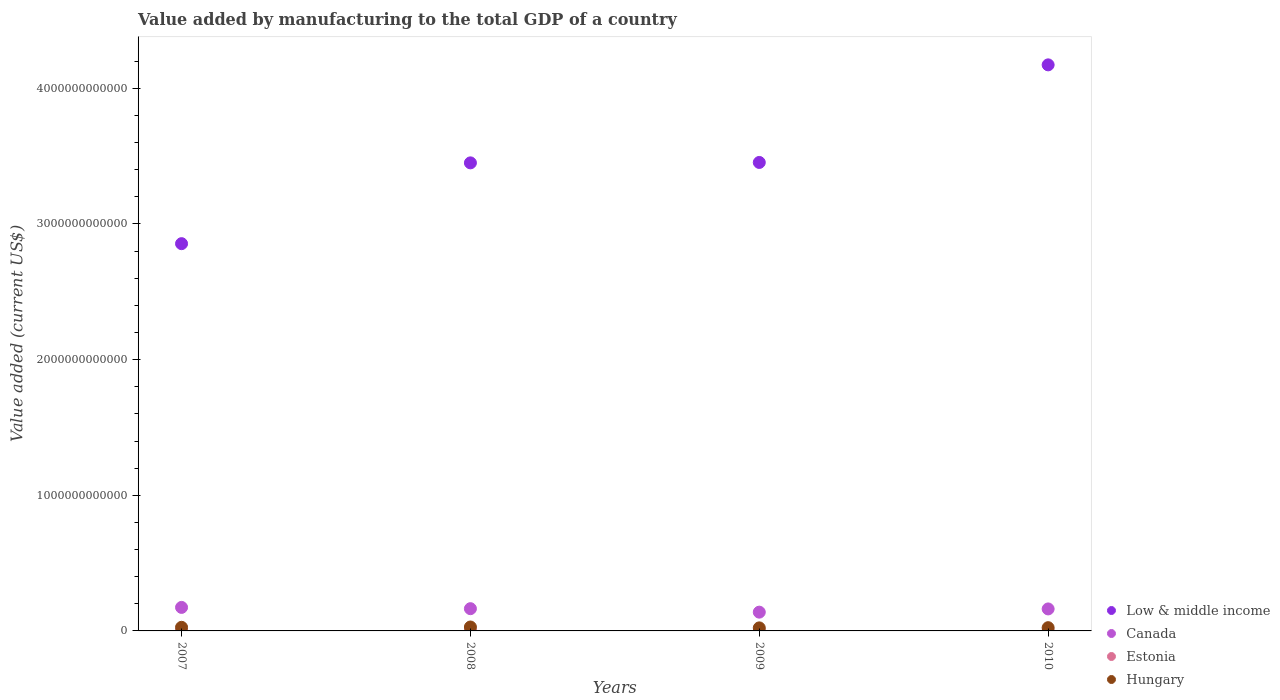How many different coloured dotlines are there?
Provide a short and direct response. 4. What is the value added by manufacturing to the total GDP in Canada in 2010?
Offer a terse response. 1.62e+11. Across all years, what is the maximum value added by manufacturing to the total GDP in Hungary?
Your answer should be very brief. 2.88e+1. Across all years, what is the minimum value added by manufacturing to the total GDP in Canada?
Offer a terse response. 1.38e+11. In which year was the value added by manufacturing to the total GDP in Estonia maximum?
Keep it short and to the point. 2008. What is the total value added by manufacturing to the total GDP in Estonia in the graph?
Your answer should be compact. 1.15e+1. What is the difference between the value added by manufacturing to the total GDP in Hungary in 2007 and that in 2010?
Offer a very short reply. 2.71e+09. What is the difference between the value added by manufacturing to the total GDP in Low & middle income in 2007 and the value added by manufacturing to the total GDP in Canada in 2009?
Provide a succinct answer. 2.72e+12. What is the average value added by manufacturing to the total GDP in Hungary per year?
Make the answer very short. 2.54e+1. In the year 2009, what is the difference between the value added by manufacturing to the total GDP in Low & middle income and value added by manufacturing to the total GDP in Canada?
Provide a short and direct response. 3.32e+12. In how many years, is the value added by manufacturing to the total GDP in Estonia greater than 1400000000000 US$?
Make the answer very short. 0. What is the ratio of the value added by manufacturing to the total GDP in Low & middle income in 2007 to that in 2009?
Give a very brief answer. 0.83. Is the value added by manufacturing to the total GDP in Estonia in 2007 less than that in 2009?
Provide a short and direct response. No. Is the difference between the value added by manufacturing to the total GDP in Low & middle income in 2009 and 2010 greater than the difference between the value added by manufacturing to the total GDP in Canada in 2009 and 2010?
Keep it short and to the point. No. What is the difference between the highest and the second highest value added by manufacturing to the total GDP in Hungary?
Your answer should be compact. 2.23e+09. What is the difference between the highest and the lowest value added by manufacturing to the total GDP in Hungary?
Make the answer very short. 6.42e+09. Is the sum of the value added by manufacturing to the total GDP in Hungary in 2007 and 2008 greater than the maximum value added by manufacturing to the total GDP in Canada across all years?
Your answer should be compact. No. Does the value added by manufacturing to the total GDP in Estonia monotonically increase over the years?
Your answer should be very brief. No. What is the difference between two consecutive major ticks on the Y-axis?
Your response must be concise. 1.00e+12. Are the values on the major ticks of Y-axis written in scientific E-notation?
Offer a terse response. No. Does the graph contain grids?
Make the answer very short. No. Where does the legend appear in the graph?
Give a very brief answer. Bottom right. How many legend labels are there?
Provide a short and direct response. 4. What is the title of the graph?
Provide a succinct answer. Value added by manufacturing to the total GDP of a country. Does "Vietnam" appear as one of the legend labels in the graph?
Offer a terse response. No. What is the label or title of the X-axis?
Your response must be concise. Years. What is the label or title of the Y-axis?
Your answer should be compact. Value added (current US$). What is the Value added (current US$) in Low & middle income in 2007?
Your answer should be very brief. 2.85e+12. What is the Value added (current US$) in Canada in 2007?
Offer a very short reply. 1.73e+11. What is the Value added (current US$) in Estonia in 2007?
Ensure brevity in your answer.  3.11e+09. What is the Value added (current US$) in Hungary in 2007?
Your answer should be very brief. 2.66e+1. What is the Value added (current US$) of Low & middle income in 2008?
Make the answer very short. 3.45e+12. What is the Value added (current US$) of Canada in 2008?
Your response must be concise. 1.64e+11. What is the Value added (current US$) of Estonia in 2008?
Offer a terse response. 3.34e+09. What is the Value added (current US$) in Hungary in 2008?
Provide a short and direct response. 2.88e+1. What is the Value added (current US$) in Low & middle income in 2009?
Give a very brief answer. 3.45e+12. What is the Value added (current US$) of Canada in 2009?
Your response must be concise. 1.38e+11. What is the Value added (current US$) of Estonia in 2009?
Keep it short and to the point. 2.41e+09. What is the Value added (current US$) in Hungary in 2009?
Offer a terse response. 2.24e+1. What is the Value added (current US$) of Low & middle income in 2010?
Make the answer very short. 4.17e+12. What is the Value added (current US$) of Canada in 2010?
Your answer should be very brief. 1.62e+11. What is the Value added (current US$) in Estonia in 2010?
Offer a terse response. 2.68e+09. What is the Value added (current US$) of Hungary in 2010?
Your answer should be very brief. 2.39e+1. Across all years, what is the maximum Value added (current US$) of Low & middle income?
Ensure brevity in your answer.  4.17e+12. Across all years, what is the maximum Value added (current US$) of Canada?
Your answer should be compact. 1.73e+11. Across all years, what is the maximum Value added (current US$) of Estonia?
Offer a very short reply. 3.34e+09. Across all years, what is the maximum Value added (current US$) of Hungary?
Make the answer very short. 2.88e+1. Across all years, what is the minimum Value added (current US$) of Low & middle income?
Provide a succinct answer. 2.85e+12. Across all years, what is the minimum Value added (current US$) in Canada?
Provide a succinct answer. 1.38e+11. Across all years, what is the minimum Value added (current US$) of Estonia?
Offer a very short reply. 2.41e+09. Across all years, what is the minimum Value added (current US$) in Hungary?
Your answer should be very brief. 2.24e+1. What is the total Value added (current US$) in Low & middle income in the graph?
Offer a very short reply. 1.39e+13. What is the total Value added (current US$) of Canada in the graph?
Your response must be concise. 6.38e+11. What is the total Value added (current US$) in Estonia in the graph?
Keep it short and to the point. 1.15e+1. What is the total Value added (current US$) of Hungary in the graph?
Ensure brevity in your answer.  1.02e+11. What is the difference between the Value added (current US$) in Low & middle income in 2007 and that in 2008?
Give a very brief answer. -5.96e+11. What is the difference between the Value added (current US$) in Canada in 2007 and that in 2008?
Your response must be concise. 9.42e+09. What is the difference between the Value added (current US$) of Estonia in 2007 and that in 2008?
Keep it short and to the point. -2.29e+08. What is the difference between the Value added (current US$) in Hungary in 2007 and that in 2008?
Your answer should be compact. -2.23e+09. What is the difference between the Value added (current US$) of Low & middle income in 2007 and that in 2009?
Ensure brevity in your answer.  -5.99e+11. What is the difference between the Value added (current US$) of Canada in 2007 and that in 2009?
Provide a short and direct response. 3.50e+1. What is the difference between the Value added (current US$) of Estonia in 2007 and that in 2009?
Offer a terse response. 6.98e+08. What is the difference between the Value added (current US$) of Hungary in 2007 and that in 2009?
Ensure brevity in your answer.  4.19e+09. What is the difference between the Value added (current US$) of Low & middle income in 2007 and that in 2010?
Provide a short and direct response. -1.32e+12. What is the difference between the Value added (current US$) in Canada in 2007 and that in 2010?
Make the answer very short. 1.13e+1. What is the difference between the Value added (current US$) in Estonia in 2007 and that in 2010?
Keep it short and to the point. 4.33e+08. What is the difference between the Value added (current US$) in Hungary in 2007 and that in 2010?
Offer a very short reply. 2.71e+09. What is the difference between the Value added (current US$) in Low & middle income in 2008 and that in 2009?
Offer a terse response. -3.05e+09. What is the difference between the Value added (current US$) in Canada in 2008 and that in 2009?
Ensure brevity in your answer.  2.56e+1. What is the difference between the Value added (current US$) in Estonia in 2008 and that in 2009?
Provide a succinct answer. 9.27e+08. What is the difference between the Value added (current US$) of Hungary in 2008 and that in 2009?
Your answer should be compact. 6.42e+09. What is the difference between the Value added (current US$) of Low & middle income in 2008 and that in 2010?
Your answer should be compact. -7.22e+11. What is the difference between the Value added (current US$) in Canada in 2008 and that in 2010?
Ensure brevity in your answer.  1.87e+09. What is the difference between the Value added (current US$) in Estonia in 2008 and that in 2010?
Your response must be concise. 6.62e+08. What is the difference between the Value added (current US$) of Hungary in 2008 and that in 2010?
Make the answer very short. 4.94e+09. What is the difference between the Value added (current US$) in Low & middle income in 2009 and that in 2010?
Ensure brevity in your answer.  -7.19e+11. What is the difference between the Value added (current US$) of Canada in 2009 and that in 2010?
Your answer should be compact. -2.37e+1. What is the difference between the Value added (current US$) in Estonia in 2009 and that in 2010?
Provide a succinct answer. -2.65e+08. What is the difference between the Value added (current US$) in Hungary in 2009 and that in 2010?
Keep it short and to the point. -1.48e+09. What is the difference between the Value added (current US$) in Low & middle income in 2007 and the Value added (current US$) in Canada in 2008?
Your answer should be compact. 2.69e+12. What is the difference between the Value added (current US$) of Low & middle income in 2007 and the Value added (current US$) of Estonia in 2008?
Your answer should be compact. 2.85e+12. What is the difference between the Value added (current US$) in Low & middle income in 2007 and the Value added (current US$) in Hungary in 2008?
Make the answer very short. 2.83e+12. What is the difference between the Value added (current US$) of Canada in 2007 and the Value added (current US$) of Estonia in 2008?
Provide a succinct answer. 1.70e+11. What is the difference between the Value added (current US$) in Canada in 2007 and the Value added (current US$) in Hungary in 2008?
Your answer should be compact. 1.45e+11. What is the difference between the Value added (current US$) of Estonia in 2007 and the Value added (current US$) of Hungary in 2008?
Offer a very short reply. -2.57e+1. What is the difference between the Value added (current US$) in Low & middle income in 2007 and the Value added (current US$) in Canada in 2009?
Give a very brief answer. 2.72e+12. What is the difference between the Value added (current US$) of Low & middle income in 2007 and the Value added (current US$) of Estonia in 2009?
Provide a short and direct response. 2.85e+12. What is the difference between the Value added (current US$) in Low & middle income in 2007 and the Value added (current US$) in Hungary in 2009?
Your response must be concise. 2.83e+12. What is the difference between the Value added (current US$) in Canada in 2007 and the Value added (current US$) in Estonia in 2009?
Provide a succinct answer. 1.71e+11. What is the difference between the Value added (current US$) in Canada in 2007 and the Value added (current US$) in Hungary in 2009?
Give a very brief answer. 1.51e+11. What is the difference between the Value added (current US$) in Estonia in 2007 and the Value added (current US$) in Hungary in 2009?
Offer a terse response. -1.93e+1. What is the difference between the Value added (current US$) of Low & middle income in 2007 and the Value added (current US$) of Canada in 2010?
Your answer should be very brief. 2.69e+12. What is the difference between the Value added (current US$) in Low & middle income in 2007 and the Value added (current US$) in Estonia in 2010?
Provide a succinct answer. 2.85e+12. What is the difference between the Value added (current US$) of Low & middle income in 2007 and the Value added (current US$) of Hungary in 2010?
Make the answer very short. 2.83e+12. What is the difference between the Value added (current US$) of Canada in 2007 and the Value added (current US$) of Estonia in 2010?
Provide a succinct answer. 1.71e+11. What is the difference between the Value added (current US$) in Canada in 2007 and the Value added (current US$) in Hungary in 2010?
Provide a short and direct response. 1.49e+11. What is the difference between the Value added (current US$) in Estonia in 2007 and the Value added (current US$) in Hungary in 2010?
Make the answer very short. -2.08e+1. What is the difference between the Value added (current US$) of Low & middle income in 2008 and the Value added (current US$) of Canada in 2009?
Provide a short and direct response. 3.31e+12. What is the difference between the Value added (current US$) in Low & middle income in 2008 and the Value added (current US$) in Estonia in 2009?
Make the answer very short. 3.45e+12. What is the difference between the Value added (current US$) in Low & middle income in 2008 and the Value added (current US$) in Hungary in 2009?
Your response must be concise. 3.43e+12. What is the difference between the Value added (current US$) in Canada in 2008 and the Value added (current US$) in Estonia in 2009?
Your answer should be compact. 1.62e+11. What is the difference between the Value added (current US$) in Canada in 2008 and the Value added (current US$) in Hungary in 2009?
Provide a succinct answer. 1.42e+11. What is the difference between the Value added (current US$) of Estonia in 2008 and the Value added (current US$) of Hungary in 2009?
Offer a very short reply. -1.91e+1. What is the difference between the Value added (current US$) of Low & middle income in 2008 and the Value added (current US$) of Canada in 2010?
Ensure brevity in your answer.  3.29e+12. What is the difference between the Value added (current US$) of Low & middle income in 2008 and the Value added (current US$) of Estonia in 2010?
Provide a short and direct response. 3.45e+12. What is the difference between the Value added (current US$) in Low & middle income in 2008 and the Value added (current US$) in Hungary in 2010?
Your answer should be compact. 3.43e+12. What is the difference between the Value added (current US$) in Canada in 2008 and the Value added (current US$) in Estonia in 2010?
Keep it short and to the point. 1.61e+11. What is the difference between the Value added (current US$) of Canada in 2008 and the Value added (current US$) of Hungary in 2010?
Offer a terse response. 1.40e+11. What is the difference between the Value added (current US$) in Estonia in 2008 and the Value added (current US$) in Hungary in 2010?
Keep it short and to the point. -2.05e+1. What is the difference between the Value added (current US$) in Low & middle income in 2009 and the Value added (current US$) in Canada in 2010?
Provide a succinct answer. 3.29e+12. What is the difference between the Value added (current US$) of Low & middle income in 2009 and the Value added (current US$) of Estonia in 2010?
Your answer should be compact. 3.45e+12. What is the difference between the Value added (current US$) in Low & middle income in 2009 and the Value added (current US$) in Hungary in 2010?
Offer a very short reply. 3.43e+12. What is the difference between the Value added (current US$) in Canada in 2009 and the Value added (current US$) in Estonia in 2010?
Ensure brevity in your answer.  1.36e+11. What is the difference between the Value added (current US$) of Canada in 2009 and the Value added (current US$) of Hungary in 2010?
Give a very brief answer. 1.14e+11. What is the difference between the Value added (current US$) in Estonia in 2009 and the Value added (current US$) in Hungary in 2010?
Provide a succinct answer. -2.15e+1. What is the average Value added (current US$) in Low & middle income per year?
Provide a succinct answer. 3.48e+12. What is the average Value added (current US$) of Canada per year?
Your response must be concise. 1.59e+11. What is the average Value added (current US$) of Estonia per year?
Offer a terse response. 2.88e+09. What is the average Value added (current US$) in Hungary per year?
Offer a very short reply. 2.54e+1. In the year 2007, what is the difference between the Value added (current US$) in Low & middle income and Value added (current US$) in Canada?
Offer a very short reply. 2.68e+12. In the year 2007, what is the difference between the Value added (current US$) in Low & middle income and Value added (current US$) in Estonia?
Give a very brief answer. 2.85e+12. In the year 2007, what is the difference between the Value added (current US$) of Low & middle income and Value added (current US$) of Hungary?
Offer a very short reply. 2.83e+12. In the year 2007, what is the difference between the Value added (current US$) in Canada and Value added (current US$) in Estonia?
Keep it short and to the point. 1.70e+11. In the year 2007, what is the difference between the Value added (current US$) in Canada and Value added (current US$) in Hungary?
Your answer should be compact. 1.47e+11. In the year 2007, what is the difference between the Value added (current US$) of Estonia and Value added (current US$) of Hungary?
Offer a terse response. -2.35e+1. In the year 2008, what is the difference between the Value added (current US$) of Low & middle income and Value added (current US$) of Canada?
Make the answer very short. 3.29e+12. In the year 2008, what is the difference between the Value added (current US$) of Low & middle income and Value added (current US$) of Estonia?
Your response must be concise. 3.45e+12. In the year 2008, what is the difference between the Value added (current US$) of Low & middle income and Value added (current US$) of Hungary?
Your answer should be compact. 3.42e+12. In the year 2008, what is the difference between the Value added (current US$) of Canada and Value added (current US$) of Estonia?
Offer a very short reply. 1.61e+11. In the year 2008, what is the difference between the Value added (current US$) of Canada and Value added (current US$) of Hungary?
Your response must be concise. 1.35e+11. In the year 2008, what is the difference between the Value added (current US$) in Estonia and Value added (current US$) in Hungary?
Offer a terse response. -2.55e+1. In the year 2009, what is the difference between the Value added (current US$) in Low & middle income and Value added (current US$) in Canada?
Your response must be concise. 3.32e+12. In the year 2009, what is the difference between the Value added (current US$) in Low & middle income and Value added (current US$) in Estonia?
Offer a very short reply. 3.45e+12. In the year 2009, what is the difference between the Value added (current US$) of Low & middle income and Value added (current US$) of Hungary?
Offer a very short reply. 3.43e+12. In the year 2009, what is the difference between the Value added (current US$) in Canada and Value added (current US$) in Estonia?
Provide a succinct answer. 1.36e+11. In the year 2009, what is the difference between the Value added (current US$) of Canada and Value added (current US$) of Hungary?
Give a very brief answer. 1.16e+11. In the year 2009, what is the difference between the Value added (current US$) in Estonia and Value added (current US$) in Hungary?
Your answer should be compact. -2.00e+1. In the year 2010, what is the difference between the Value added (current US$) in Low & middle income and Value added (current US$) in Canada?
Your answer should be compact. 4.01e+12. In the year 2010, what is the difference between the Value added (current US$) of Low & middle income and Value added (current US$) of Estonia?
Offer a very short reply. 4.17e+12. In the year 2010, what is the difference between the Value added (current US$) of Low & middle income and Value added (current US$) of Hungary?
Offer a very short reply. 4.15e+12. In the year 2010, what is the difference between the Value added (current US$) in Canada and Value added (current US$) in Estonia?
Give a very brief answer. 1.59e+11. In the year 2010, what is the difference between the Value added (current US$) of Canada and Value added (current US$) of Hungary?
Your response must be concise. 1.38e+11. In the year 2010, what is the difference between the Value added (current US$) of Estonia and Value added (current US$) of Hungary?
Give a very brief answer. -2.12e+1. What is the ratio of the Value added (current US$) of Low & middle income in 2007 to that in 2008?
Your answer should be compact. 0.83. What is the ratio of the Value added (current US$) of Canada in 2007 to that in 2008?
Offer a very short reply. 1.06. What is the ratio of the Value added (current US$) of Estonia in 2007 to that in 2008?
Ensure brevity in your answer.  0.93. What is the ratio of the Value added (current US$) of Hungary in 2007 to that in 2008?
Offer a very short reply. 0.92. What is the ratio of the Value added (current US$) of Low & middle income in 2007 to that in 2009?
Offer a very short reply. 0.83. What is the ratio of the Value added (current US$) in Canada in 2007 to that in 2009?
Ensure brevity in your answer.  1.25. What is the ratio of the Value added (current US$) of Estonia in 2007 to that in 2009?
Keep it short and to the point. 1.29. What is the ratio of the Value added (current US$) of Hungary in 2007 to that in 2009?
Provide a succinct answer. 1.19. What is the ratio of the Value added (current US$) in Low & middle income in 2007 to that in 2010?
Your answer should be compact. 0.68. What is the ratio of the Value added (current US$) of Canada in 2007 to that in 2010?
Your answer should be very brief. 1.07. What is the ratio of the Value added (current US$) in Estonia in 2007 to that in 2010?
Your answer should be compact. 1.16. What is the ratio of the Value added (current US$) of Hungary in 2007 to that in 2010?
Give a very brief answer. 1.11. What is the ratio of the Value added (current US$) of Canada in 2008 to that in 2009?
Ensure brevity in your answer.  1.19. What is the ratio of the Value added (current US$) in Estonia in 2008 to that in 2009?
Offer a terse response. 1.38. What is the ratio of the Value added (current US$) of Hungary in 2008 to that in 2009?
Offer a very short reply. 1.29. What is the ratio of the Value added (current US$) in Low & middle income in 2008 to that in 2010?
Make the answer very short. 0.83. What is the ratio of the Value added (current US$) of Canada in 2008 to that in 2010?
Ensure brevity in your answer.  1.01. What is the ratio of the Value added (current US$) of Estonia in 2008 to that in 2010?
Keep it short and to the point. 1.25. What is the ratio of the Value added (current US$) in Hungary in 2008 to that in 2010?
Provide a short and direct response. 1.21. What is the ratio of the Value added (current US$) of Low & middle income in 2009 to that in 2010?
Ensure brevity in your answer.  0.83. What is the ratio of the Value added (current US$) of Canada in 2009 to that in 2010?
Offer a very short reply. 0.85. What is the ratio of the Value added (current US$) in Estonia in 2009 to that in 2010?
Your answer should be compact. 0.9. What is the ratio of the Value added (current US$) in Hungary in 2009 to that in 2010?
Give a very brief answer. 0.94. What is the difference between the highest and the second highest Value added (current US$) of Low & middle income?
Offer a very short reply. 7.19e+11. What is the difference between the highest and the second highest Value added (current US$) in Canada?
Give a very brief answer. 9.42e+09. What is the difference between the highest and the second highest Value added (current US$) of Estonia?
Provide a short and direct response. 2.29e+08. What is the difference between the highest and the second highest Value added (current US$) of Hungary?
Your answer should be very brief. 2.23e+09. What is the difference between the highest and the lowest Value added (current US$) in Low & middle income?
Your answer should be very brief. 1.32e+12. What is the difference between the highest and the lowest Value added (current US$) in Canada?
Offer a very short reply. 3.50e+1. What is the difference between the highest and the lowest Value added (current US$) in Estonia?
Your response must be concise. 9.27e+08. What is the difference between the highest and the lowest Value added (current US$) of Hungary?
Provide a succinct answer. 6.42e+09. 